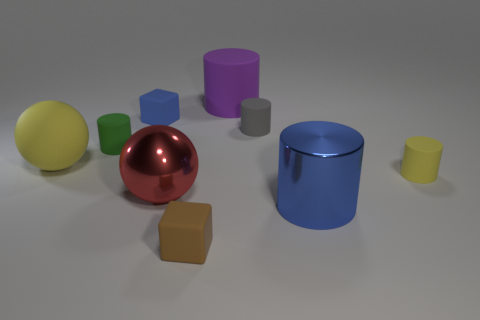Subtract all gray matte cylinders. How many cylinders are left? 4 Subtract all green cylinders. How many cylinders are left? 4 Subtract 0 brown cylinders. How many objects are left? 9 Subtract all cubes. How many objects are left? 7 Subtract 2 balls. How many balls are left? 0 Subtract all purple balls. Subtract all green cylinders. How many balls are left? 2 Subtract all purple cubes. How many purple balls are left? 0 Subtract all large red shiny objects. Subtract all blue shiny things. How many objects are left? 7 Add 6 small matte cylinders. How many small matte cylinders are left? 9 Add 6 big purple matte objects. How many big purple matte objects exist? 7 